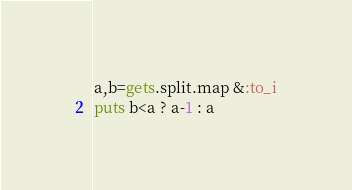<code> <loc_0><loc_0><loc_500><loc_500><_Ruby_>a,b=gets.split.map &:to_i
puts b<a ? a-1 : a</code> 